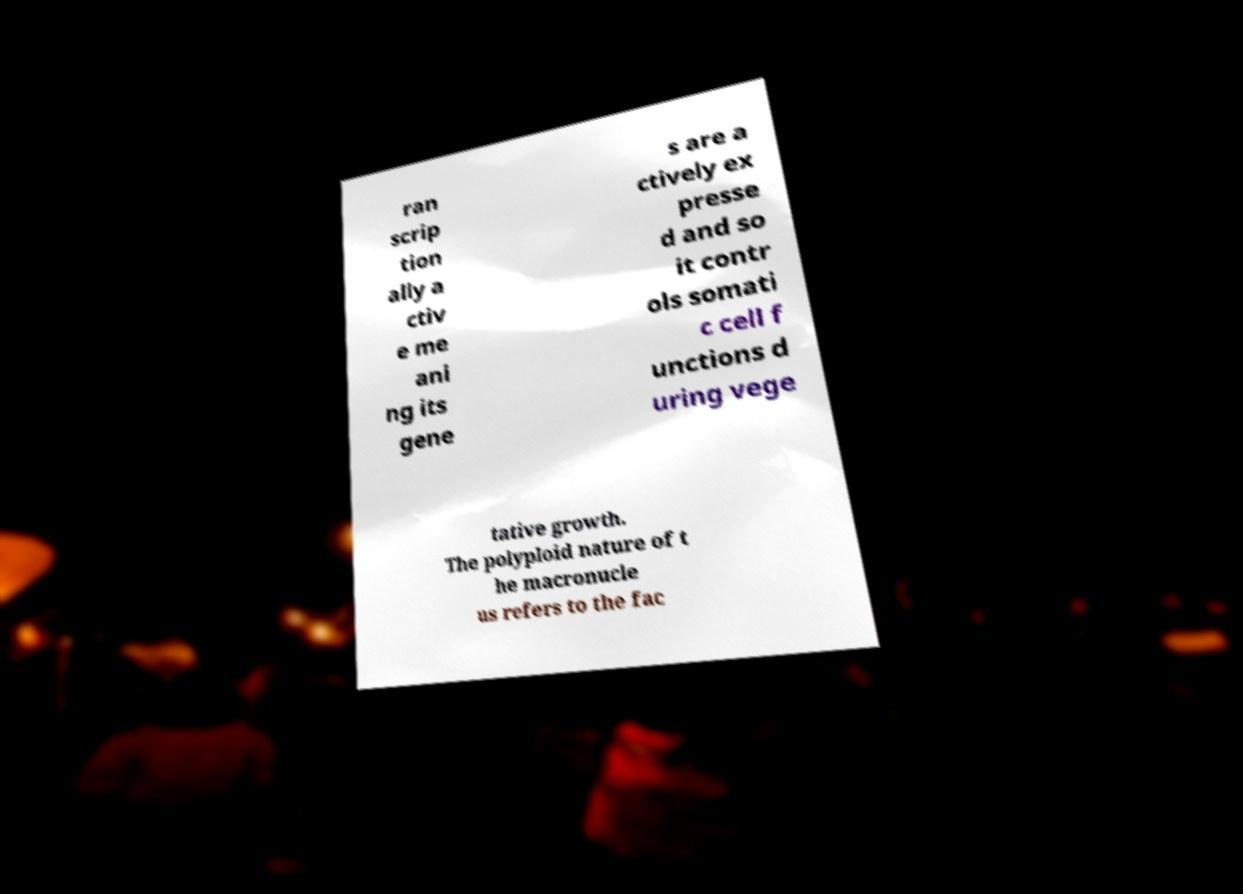I need the written content from this picture converted into text. Can you do that? ran scrip tion ally a ctiv e me ani ng its gene s are a ctively ex presse d and so it contr ols somati c cell f unctions d uring vege tative growth. The polyploid nature of t he macronucle us refers to the fac 